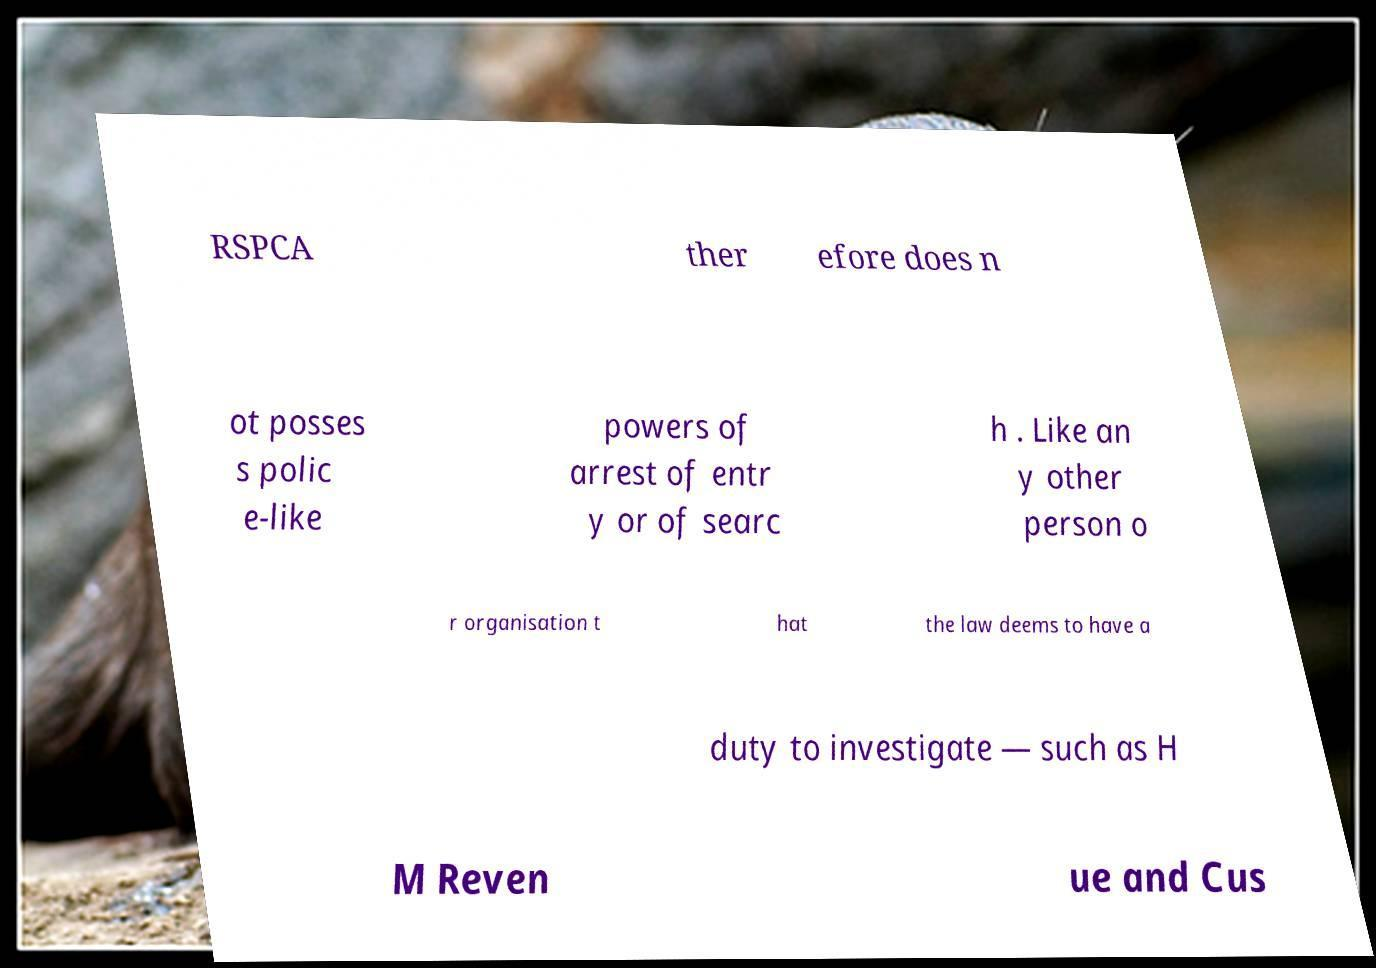Can you read and provide the text displayed in the image?This photo seems to have some interesting text. Can you extract and type it out for me? RSPCA ther efore does n ot posses s polic e-like powers of arrest of entr y or of searc h . Like an y other person o r organisation t hat the law deems to have a duty to investigate — such as H M Reven ue and Cus 